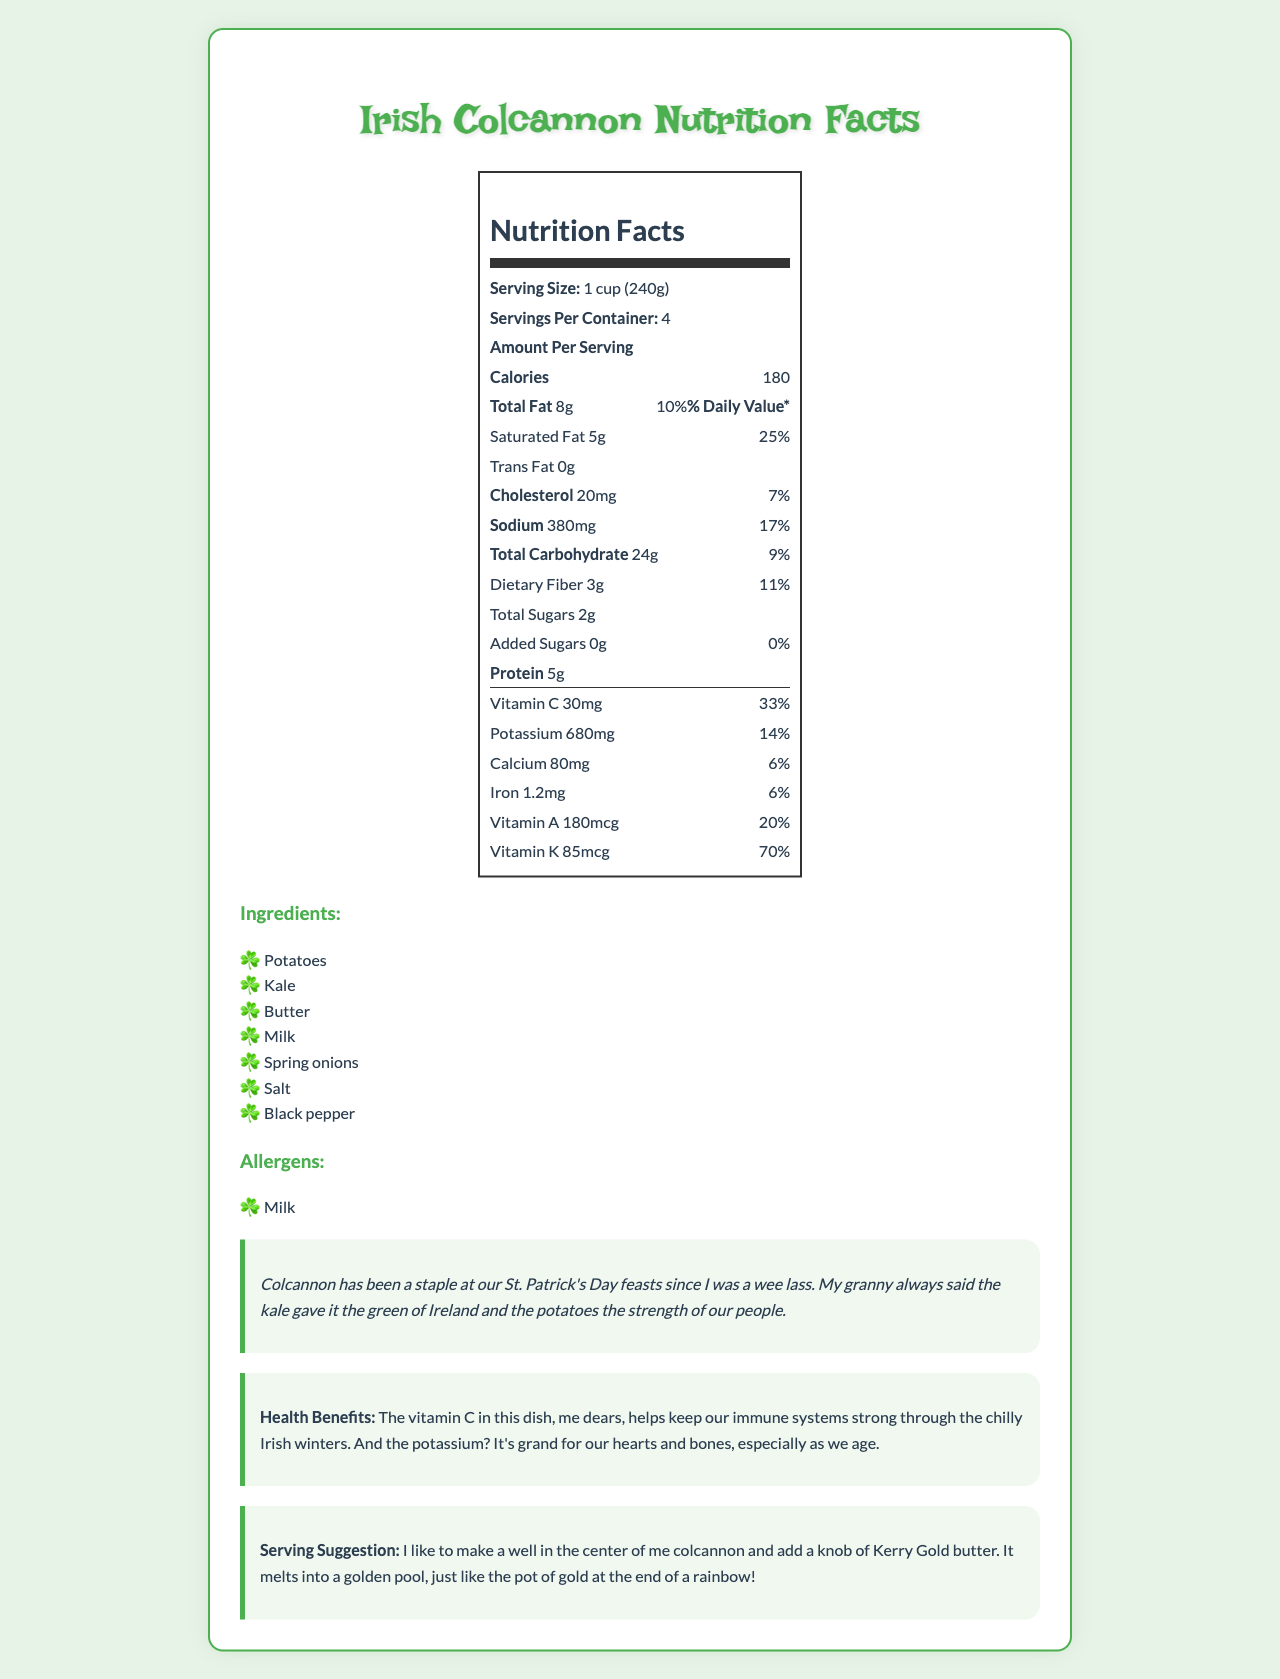what is the serving size of the Irish Colcannon? The serving size is listed directly under the Nutrition Facts section as "Serving Size: 1 cup (240g)".
Answer: 1 cup (240g) how many servings are in the container? The servings per container are listed directly under the serving size as "Servings Per Container: 4".
Answer: 4 how many milligrams of vitamin C are in one serving? The amount of vitamin C is listed in the vitamins section as "Vitamin C 30mg".
Answer: 30mg how much potassium does one serving provide? The amount of potassium is listed in the vitamins section as "Potassium 680mg".
Answer: 680mg what percentage of the daily value of vitamin C does one serving provide? The percentage of the daily value for vitamin C is listed next to its amount in the vitamins section as "Vitamin C 30mg 33%".
Answer: 33% describe the tradition mentioned about Colcannon. The section under "Tradition" describes how Colcannon has been a part of St. Patrick's Day feasts and its symbolic significance.
Answer: Colcannon has been a staple at St. Patrick's Day feasts, and the tradition relates to it representing the green of Ireland and the strength of its people. what ingredient gives the green color to Colcannon according to the tradition? The tradition section mentions that "the kale gave it the green of Ireland".
Answer: Kale how many grams of dietary fiber are in one serving? The amount of dietary fiber is listed under the Total Carbohydrate section as "Dietary Fiber 3g".
Answer: 3g which vitamin has the highest percentage of daily value in Colcannon? A. Vitamin A B. Vitamin K C. Vitamin C The vitamins section lists the daily values, with Vitamin K having 70%, Vitamin A 20%, and Vitamin C 33%.
Answer: B. Vitamin K how much protein is in one serving of the Colcannon? A. 5g B. 4g C. 6g The protein content is listed under the Amount Per Serving section as "Protein 5g".
Answer: A. 5g is there any trans fat in the Colcannon? The trans fat amount is listed as "0g" under the Total Fat section.
Answer: No summarize the health benefits mentioned for the Colcannon. The health benefits section explains how vitamin C helps the immune system and potassium is good for heart and bone health.
Answer: Vitamin C boosts the immune system, and potassium benefits the heart and bones, especially for the elderly. does the ingredient list include allergens? If so, name one. The allergens section lists "Milk" as an allergen.
Answer: Yes, Milk how much calcium is in one serving? The amount of calcium is listed in the vitamins section as "Calcium 80mg".
Answer: 80mg what is the tradition associated with serving Colcannon? The serving suggestion section describes creating a well in the center and adding Kerry Gold butter which melts into a golden pool.
Answer: Making a well in the center and adding a knob of Kerry Gold butter. how many grams of total sugars are in one serving? The amount of total sugars is listed under the Total Carbohydrate section as "Total Sugars 2g".
Answer: 2g how is the golden pool in the serving suggestion described in relation to Irish mythology? The serving suggestion section mentions that the melted butter resembles a pot of gold at the end of a rainbow.
Answer: Like the pot of gold at the end of a rainbow. what is the total calorie content for one serving? The calories per serving are listed under the Amount Per Serving section as "Calories 180".
Answer: 180 calories what is the source of cholesterol in the Colcannon? The document does not specify which ingredient contributes to the cholesterol content.
Answer: Not enough information what is the total amount of added sugars in one serving? The amount of added sugars is listed under the Total Carbohydrate section as "Added Sugars 0g".
Answer: 0g what is one benefit of potassium mentioned in the document? The health benefits section explains that potassium is beneficial for heart and bone health.
Answer: Good for heart and bones 